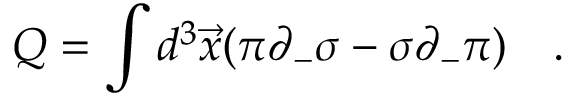<formula> <loc_0><loc_0><loc_500><loc_500>Q = \int d ^ { 3 } \vec { x } ( \pi \partial _ { - } \sigma - \sigma \partial _ { - } \pi ) \quad .</formula> 